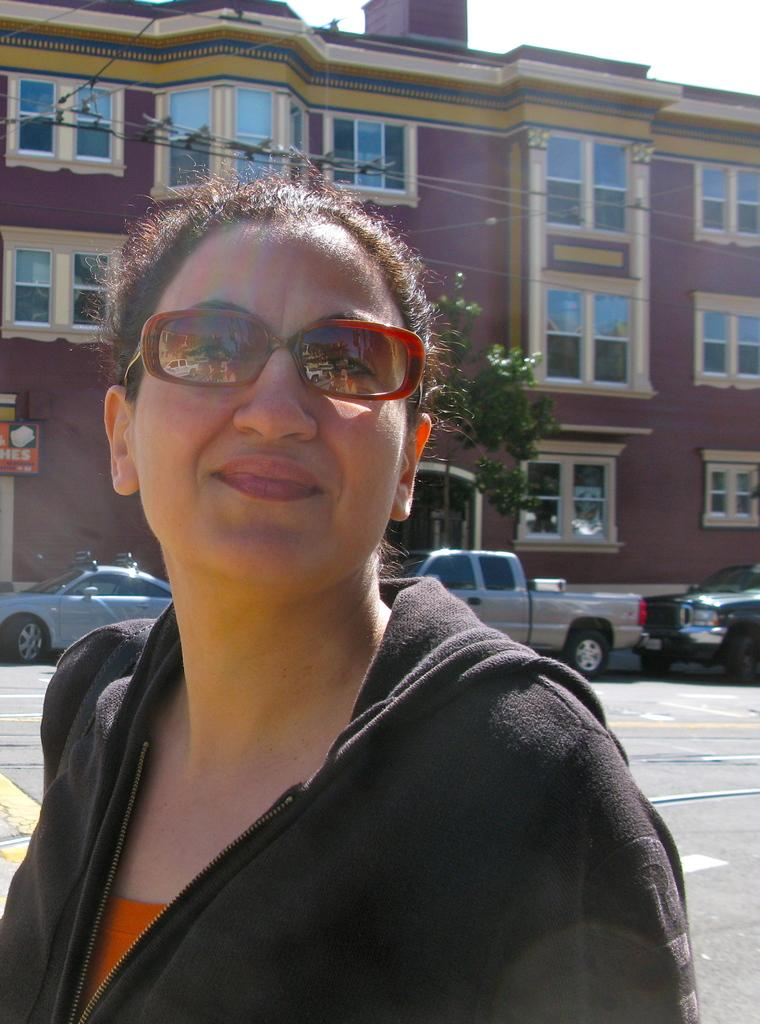Who is the main subject in the image? There is a lady in the image. What is the lady wearing in the image? The lady is wearing glasses in the image. What can be seen in the background of the image? There is a building, cars, wires, and a tree visible in the background of the image. What is visible at the top of the image? The sky is visible at the top of the image. What type of horse can be seen participating in the protest in the image? There is no horse or protest present in the image; it features a lady wearing glasses with a background that includes a building, cars, wires, and a tree. 